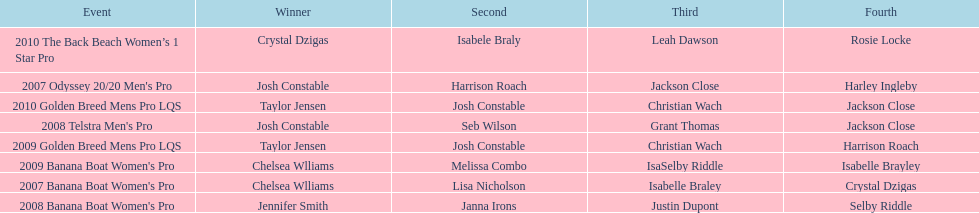Who was the top performer in the 2008 telstra men's pro? Josh Constable. 